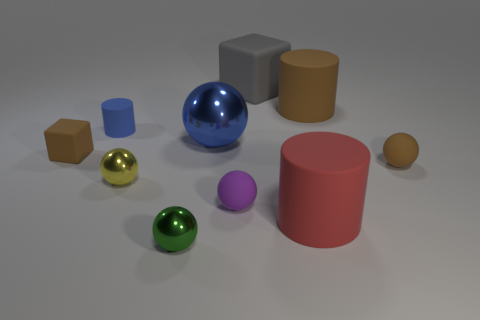Subtract all tiny rubber spheres. How many spheres are left? 3 Subtract all brown cylinders. How many cylinders are left? 2 Subtract 1 blue spheres. How many objects are left? 9 Subtract all cylinders. How many objects are left? 7 Subtract 3 cylinders. How many cylinders are left? 0 Subtract all brown blocks. Subtract all gray cylinders. How many blocks are left? 1 Subtract all red balls. How many brown blocks are left? 1 Subtract all brown matte balls. Subtract all small purple things. How many objects are left? 8 Add 1 tiny matte cylinders. How many tiny matte cylinders are left? 2 Add 10 large green rubber cylinders. How many large green rubber cylinders exist? 10 